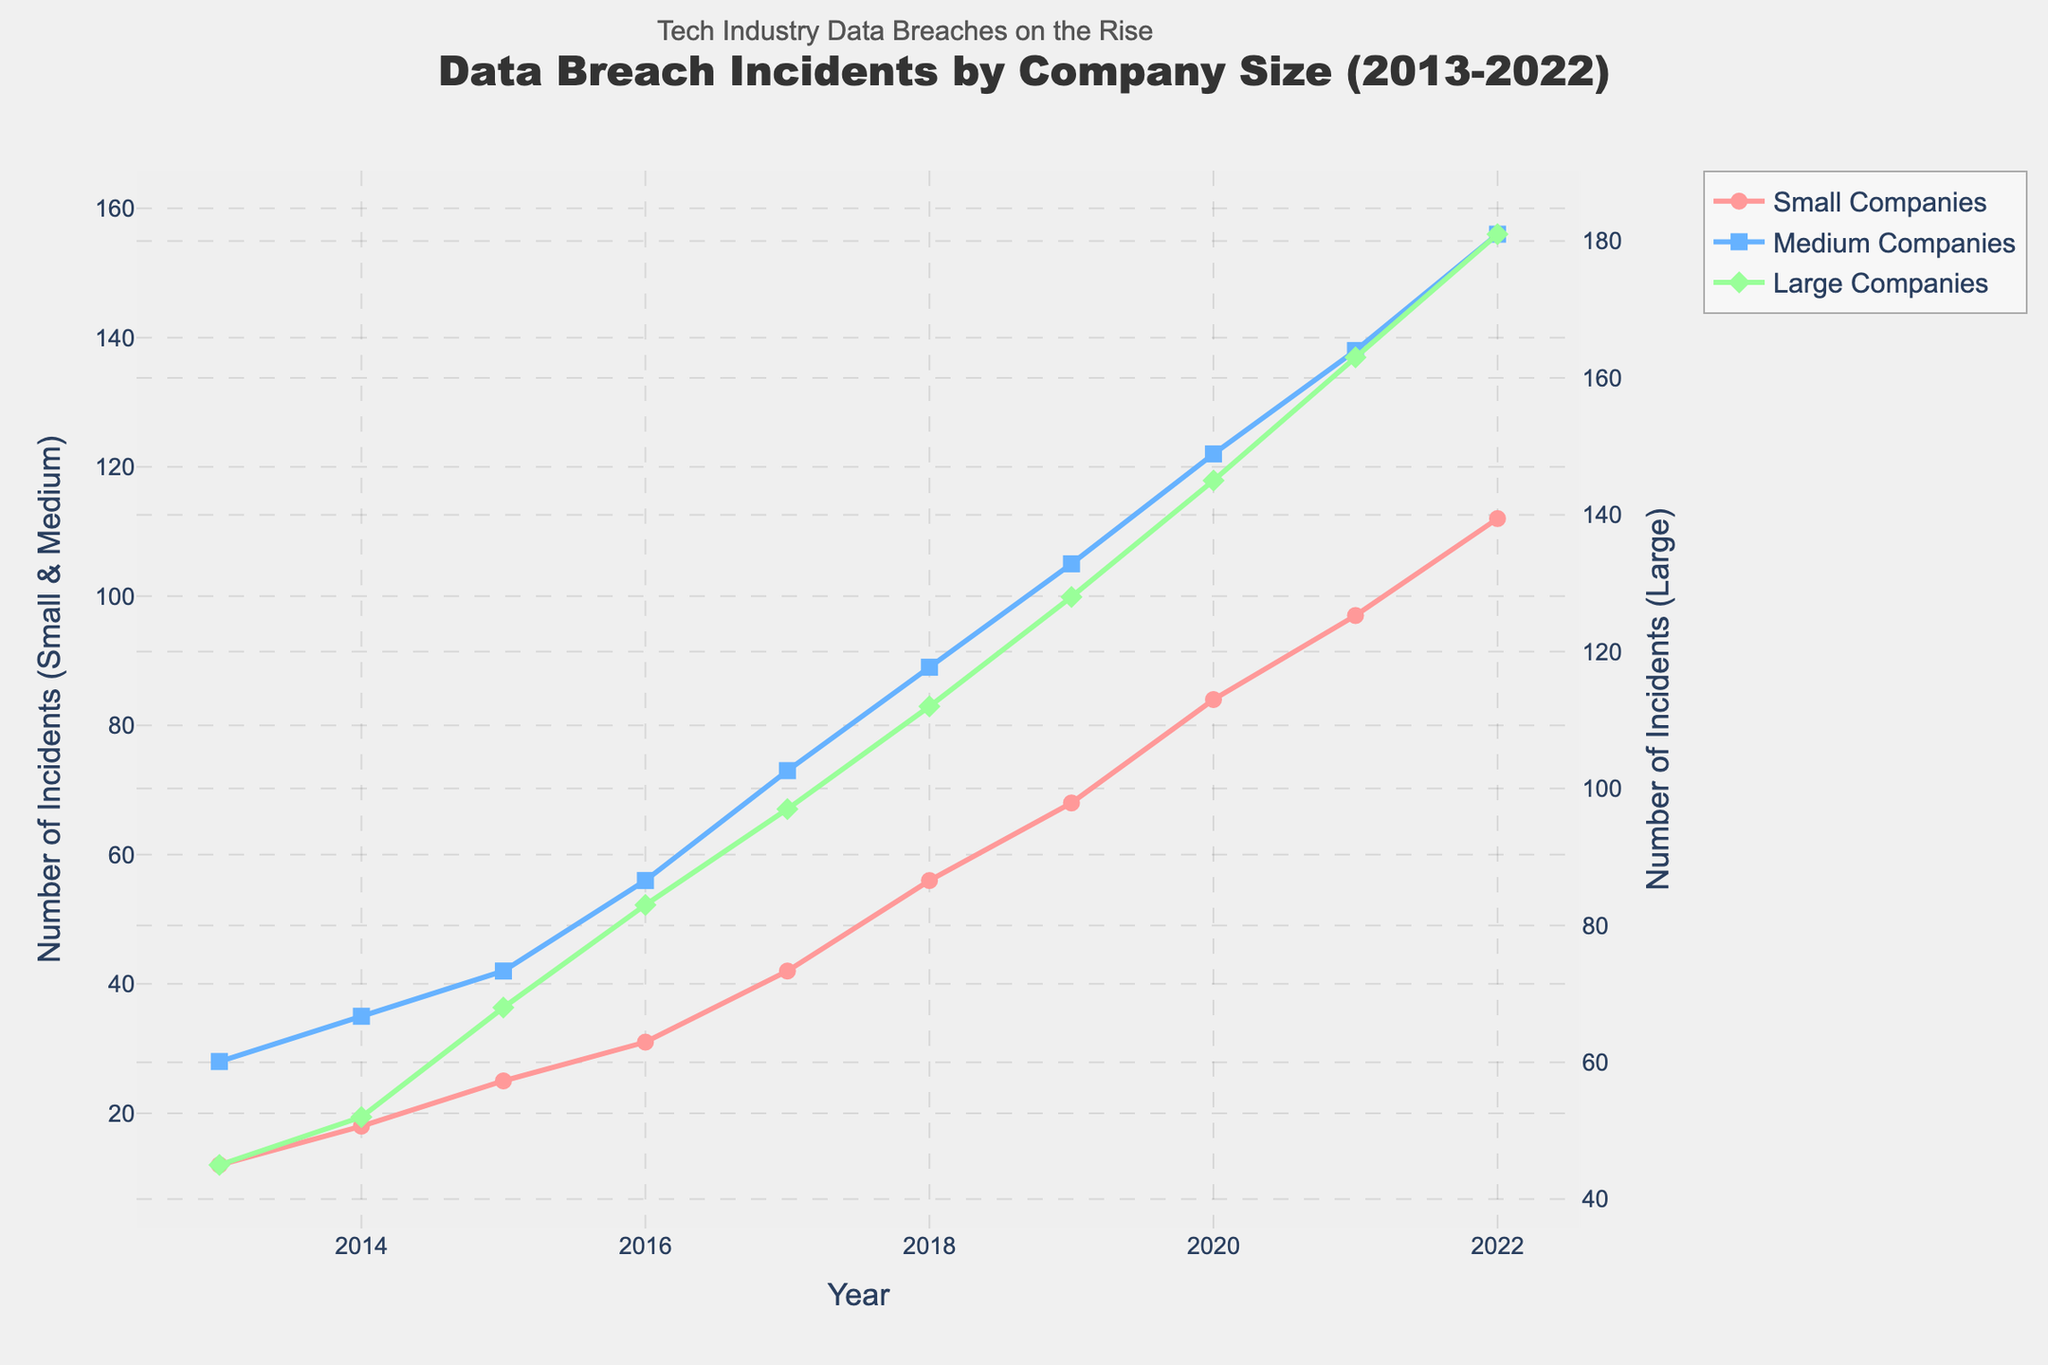What is the difference in the number of data breach incidents between small and large companies in 2013? To find the answer, locate the values for small and large companies in 2013. For small companies, it is 12 incidents, and for large companies, it is 45 incidents. The difference is 45 - 12.
Answer: 33 Between which years did medium-sized companies experience the greatest increase in data breach incidents? First, calculate the yearly increases for medium-sized companies and compare them. The biggest increase is between 2016 and 2017: 73 - 56 = 17 incidents.
Answer: 2016 to 2017 In 2022, by how many data breach incidents did medium companies surpass small companies? Locate the 2022 values for medium (156 incidents) and small (112 incidents) companies. Subtract the small from the medium: 156 - 112.
Answer: 44 How much did the number of incidents for small companies increase from 2015 to 2018? Find the values for small companies in 2015 (25 incidents) and 2018 (56 incidents). The increase is 56 - 25.
Answer: 31 What is the average number of data breach incidents for large companies over the decade? Sum up the incidents for large companies over the years from 2013 to 2022 and divide by 10. The total is 45 + 52 + 68 + 83 + 97 + 112 + 128 + 145 + 163 + 181 = 1074. Divide 1074 by 10.
Answer: 107.4 Which company size had the fewest data breaches in 2017? Check the 2017 data. Small companies had 42 incidents, medium companies had 73, and large companies had 97. Compare the values.
Answer: Small companies How does the trend in data breach incidents for small companies compare to medium companies over the decade? Observe both lines for small and medium companies from 2013 to 2022. Small companies' incidents increased from 12 to 112; medium companies increased from 28 to 156. Both show upward trends, with medium companies having larger increases.
Answer: Both increased, but medium companies had larger increases In what year did large companies exceed 100 incidents for the first time? Look for the first year where the line for large companies crosses the 100 incident mark. It is in 2018 with 112 incidents.
Answer: 2018 What is the total number of data breach incidents for small companies from 2013 to 2016? Add the incidents for small companies from 2013 to 2016: 12 + 18 + 25 + 31. The sum is 86.
Answer: 86 How do the number of incidents for large companies in 2017 compare to those in 2020? Compare the values for large companies in 2017 (97 incidents) and 2020 (145 incidents). 145 - 97 shows an increase.
Answer: Increased by 48 